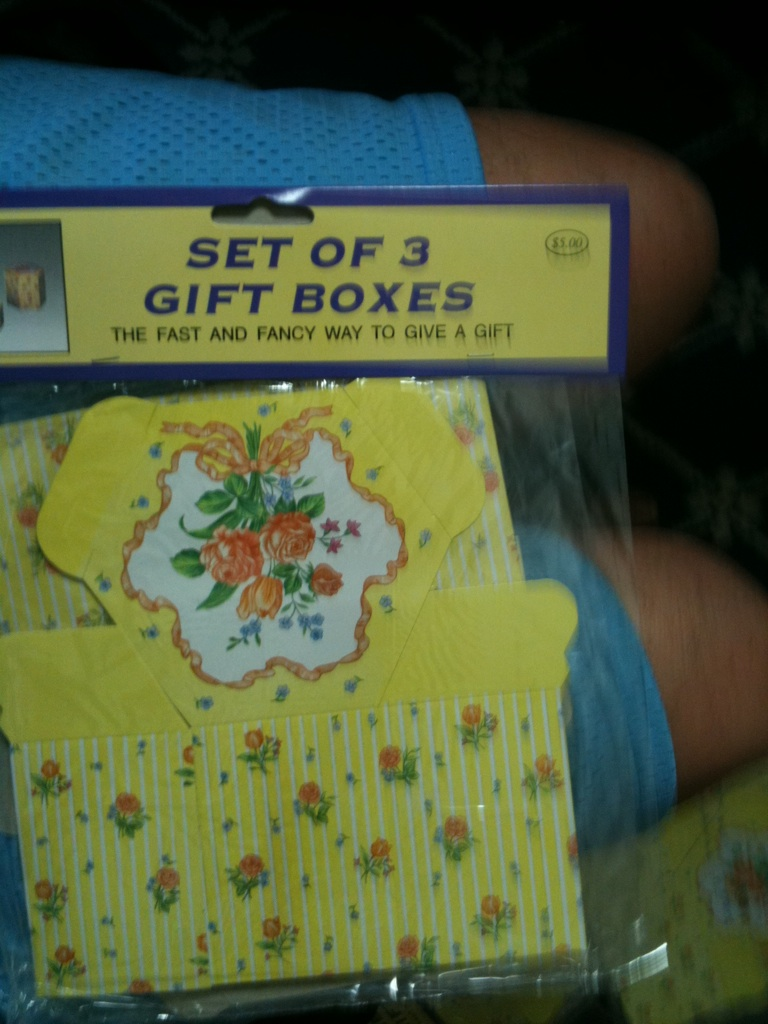Could you describe the design on the boxes more closely? Certainly! The boxes feature a charming floral design with bright orange roses accented by smaller blue and pink flowers. The background has a yellow and white striped pattern that adds a cheerful contrast to the floral theme. What is this item’s packaging made of? The gift boxes are encased in a clear plastic wrap which helps protect the boxes and keeps them in pristine condition while also allowing their beautiful designs to be displayed. 